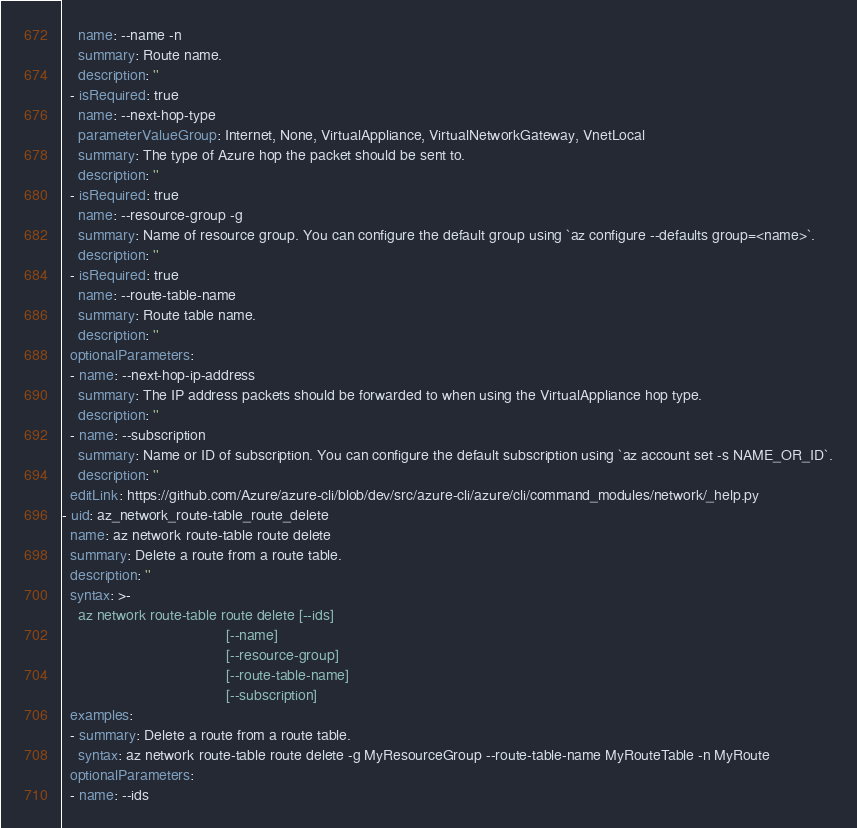Convert code to text. <code><loc_0><loc_0><loc_500><loc_500><_YAML_>    name: --name -n
    summary: Route name.
    description: ''
  - isRequired: true
    name: --next-hop-type
    parameterValueGroup: Internet, None, VirtualAppliance, VirtualNetworkGateway, VnetLocal
    summary: The type of Azure hop the packet should be sent to.
    description: ''
  - isRequired: true
    name: --resource-group -g
    summary: Name of resource group. You can configure the default group using `az configure --defaults group=<name>`.
    description: ''
  - isRequired: true
    name: --route-table-name
    summary: Route table name.
    description: ''
  optionalParameters:
  - name: --next-hop-ip-address
    summary: The IP address packets should be forwarded to when using the VirtualAppliance hop type.
    description: ''
  - name: --subscription
    summary: Name or ID of subscription. You can configure the default subscription using `az account set -s NAME_OR_ID`.
    description: ''
  editLink: https://github.com/Azure/azure-cli/blob/dev/src/azure-cli/azure/cli/command_modules/network/_help.py
- uid: az_network_route-table_route_delete
  name: az network route-table route delete
  summary: Delete a route from a route table.
  description: ''
  syntax: >-
    az network route-table route delete [--ids]
                                        [--name]
                                        [--resource-group]
                                        [--route-table-name]
                                        [--subscription]
  examples:
  - summary: Delete a route from a route table.
    syntax: az network route-table route delete -g MyResourceGroup --route-table-name MyRouteTable -n MyRoute
  optionalParameters:
  - name: --ids</code> 